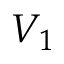Convert formula to latex. <formula><loc_0><loc_0><loc_500><loc_500>V _ { 1 }</formula> 